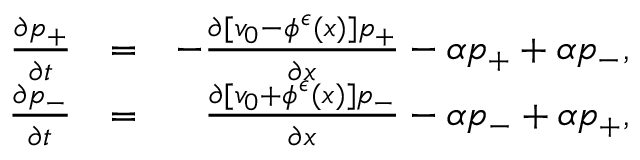Convert formula to latex. <formula><loc_0><loc_0><loc_500><loc_500>\begin{array} { r l r } { \frac { \partial p _ { + } } { \partial t } } & { = } & { - \frac { \partial [ v _ { 0 } - \phi ^ { \epsilon } ( x ) ] p _ { + } } { \partial x } - \alpha p _ { + } + \alpha p _ { - } , } \\ { \frac { \partial p _ { - } } { \partial t } } & { = } & { \frac { \partial [ v _ { 0 } + \phi ^ { \epsilon } ( x ) ] p _ { - } } { \partial x } - \alpha p _ { - } + \alpha p _ { + } , } \end{array}</formula> 